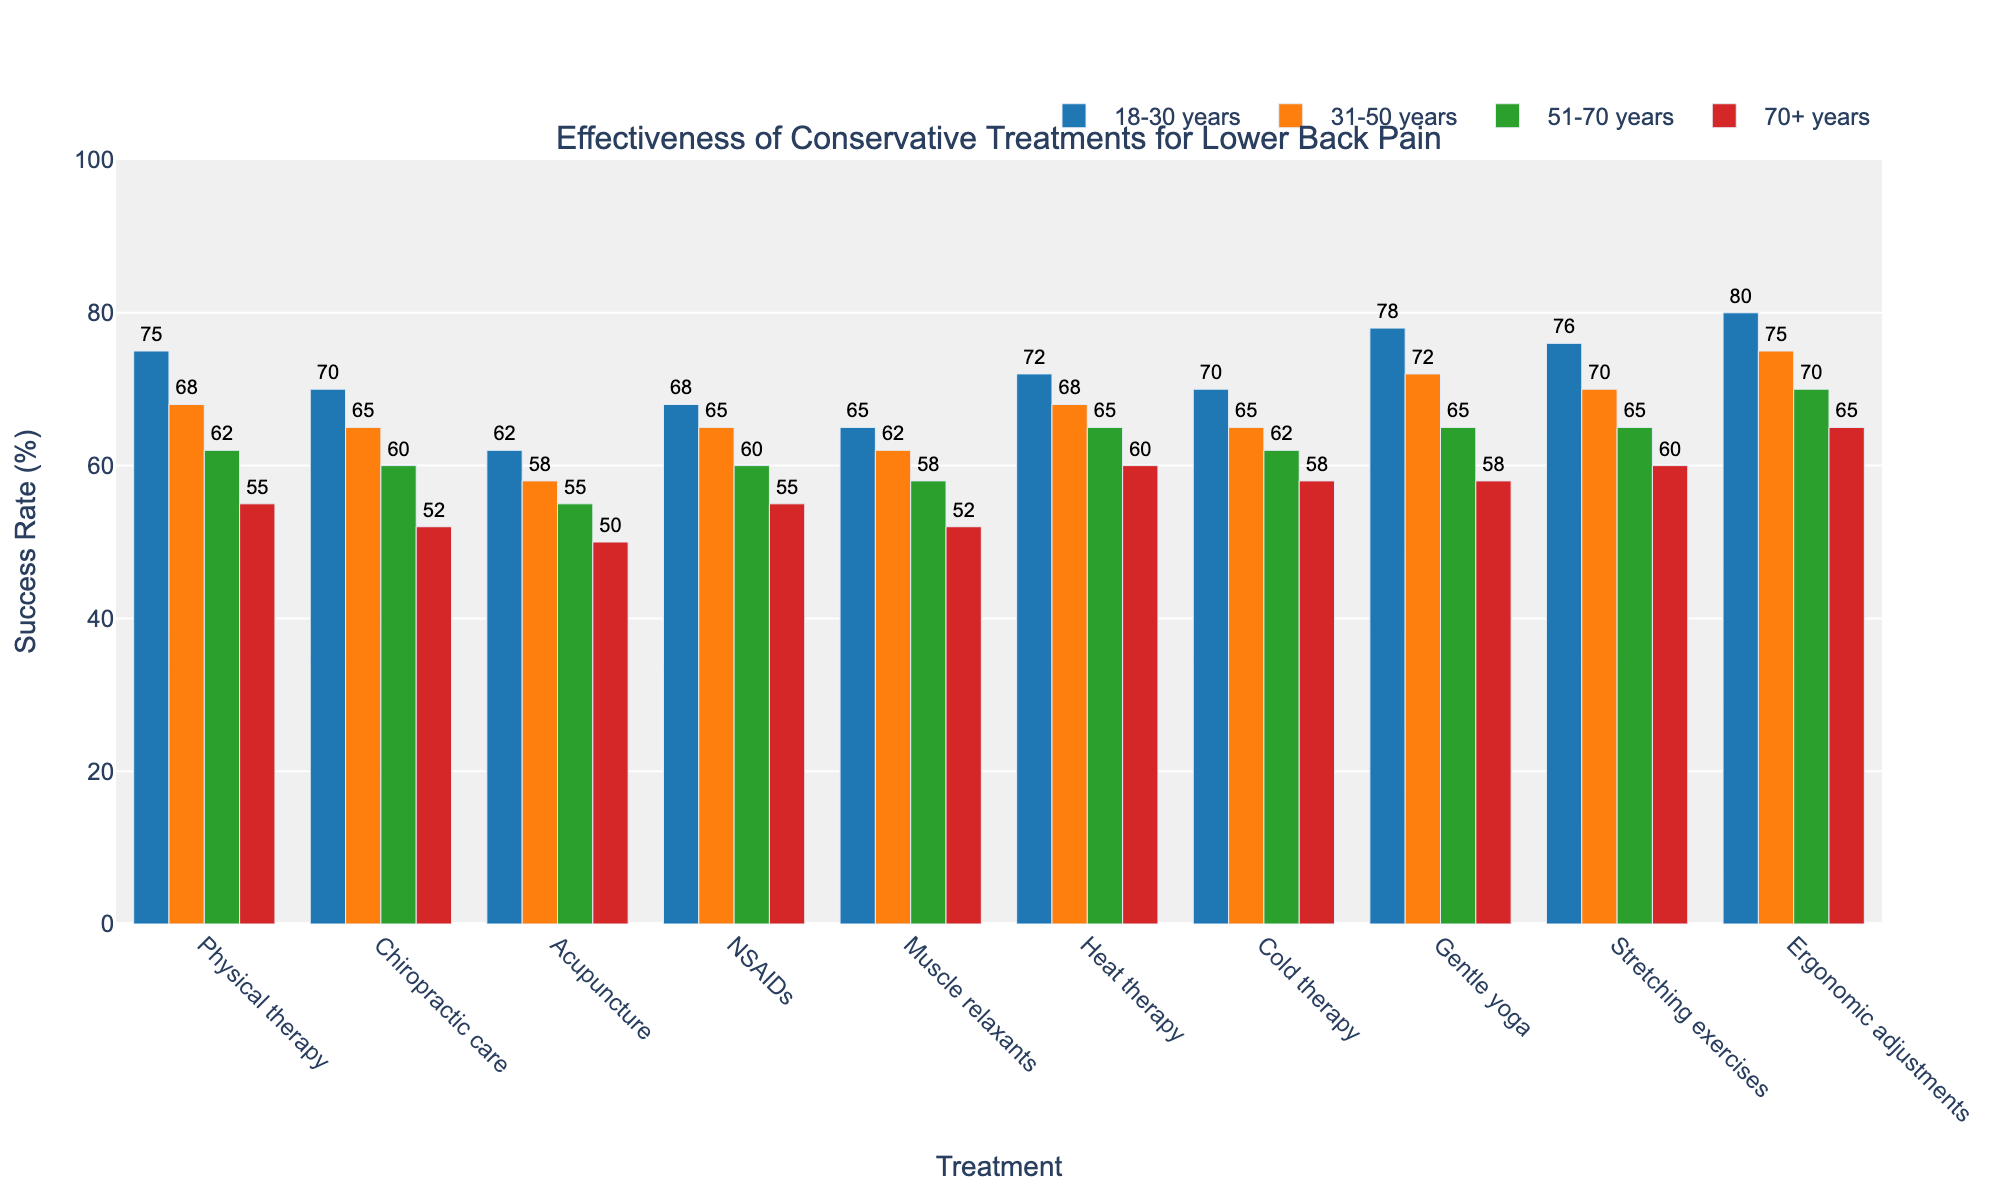Which treatment shows the highest effectiveness for the 18-30 years age group? Look at the height of the bars specifically for the 18-30 years age group and compare their values. The tallest bar will represent the highest effectiveness.
Answer: Ergonomic adjustments Which treatment shows the lowest effectiveness for the 70+ years age group? Look at the height of the bars specifically for the 70+ years age group and compare their values. The shortest bar will represent the lowest effectiveness.
Answer: Acupuncture Which age group shows the highest success rate for gentle yoga? Identify the bars representing gentle yoga and compare their heights across different age groups to find the highest one.
Answer: 18-30 years Which age group shows the smallest difference in success rates between physical therapy and chiropractic care? Calculate the difference in success rates for physical therapy and chiropractic care for each age group and identify the smallest difference. For example, 18-30 years: 75-70 = 5, 31-50 years: 68-65 = 3, etc.
Answer: 31-50 years Which treatment shows an increasing success rate trend as the age groups progress from 18-30 years to 70+ years? Observe the trend in bar heights across all age groups for each treatment and identify the one where the heights consistently increase.
Answer: Ergonomic adjustments Are success rates for stretching exercises higher for the 18-30 years or 51-70 years age group? Compare the heights of the bars for stretching exercises for the 18-30 years and 51-70 years age groups.
Answer: 18-30 years What is the average success rate for cold therapy across all age groups? Sum the success rates for cold therapy across all age groups and divide by the number of age groups: (70+65+62+58)/4.
Answer: 63.75 Which treatment has the closest success rate values for the 18-30 years and 31-50 years age groups? Find the differences in success rates between the 18-30 years and 31-50 years age groups for each treatment and identify the smallest difference. For example, physical therapy: 75-68 = 7, chiropractic care: 70-65 = 5, etc.
Answer: Heat therapy Which treatment shows a higher success rate for the 51-70 years age group as compared to NSAIDs? Identify the bars that represent the 51-70 years age group and compare their success rates with NSAIDs for the same age group. The treatment with a higher value will be the answer.
Answer: Ergonomic adjustments Is the success rate of muscle relaxants for the 31-50 years age group closer to that of cold therapy or stretching exercises? Compare the success rate of muscle relaxants for the 31-50 years age group with those of both cold therapy and stretching exercises for the same age group, and identify which one is closer.
Answer: Cold therapy 